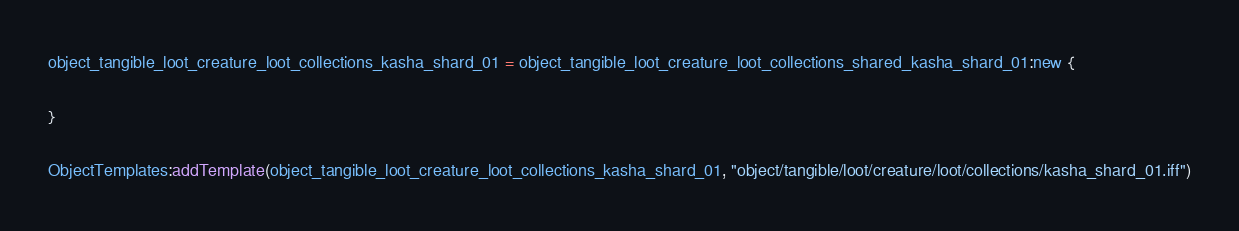<code> <loc_0><loc_0><loc_500><loc_500><_Lua_>object_tangible_loot_creature_loot_collections_kasha_shard_01 = object_tangible_loot_creature_loot_collections_shared_kasha_shard_01:new {

}

ObjectTemplates:addTemplate(object_tangible_loot_creature_loot_collections_kasha_shard_01, "object/tangible/loot/creature/loot/collections/kasha_shard_01.iff")
</code> 